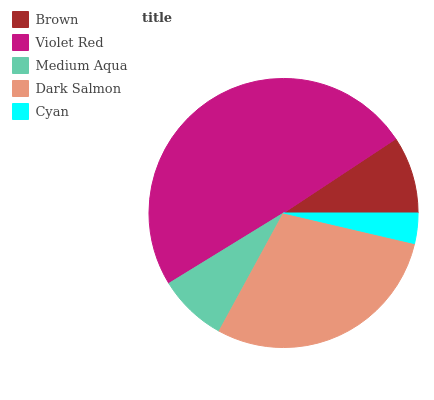Is Cyan the minimum?
Answer yes or no. Yes. Is Violet Red the maximum?
Answer yes or no. Yes. Is Medium Aqua the minimum?
Answer yes or no. No. Is Medium Aqua the maximum?
Answer yes or no. No. Is Violet Red greater than Medium Aqua?
Answer yes or no. Yes. Is Medium Aqua less than Violet Red?
Answer yes or no. Yes. Is Medium Aqua greater than Violet Red?
Answer yes or no. No. Is Violet Red less than Medium Aqua?
Answer yes or no. No. Is Brown the high median?
Answer yes or no. Yes. Is Brown the low median?
Answer yes or no. Yes. Is Dark Salmon the high median?
Answer yes or no. No. Is Medium Aqua the low median?
Answer yes or no. No. 